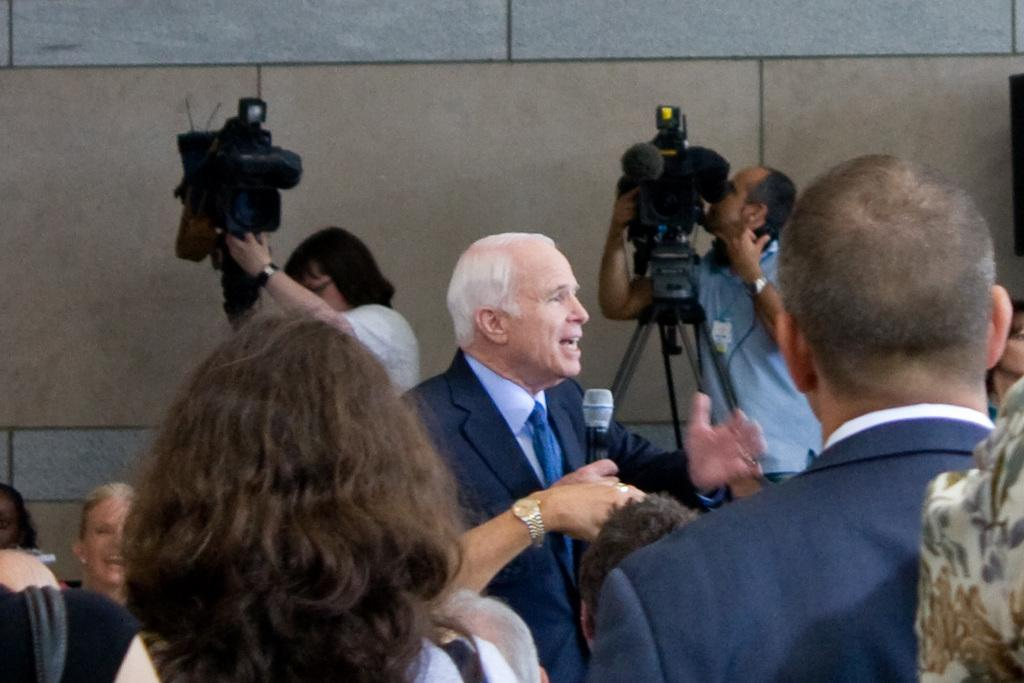How many people are in the image? There is a group of people in the image. What is the person in front wearing? The person in front is wearing a black blazer. What is the person in front holding? The person in front is holding a microphone. What can be seen in the background of the image? There are two cameras in the background, and the wall has brown and gray colors. Is the father in the image holding an umbrella to protect the group from the rain? There is no mention of rain or an umbrella in the image, nor is there any reference to a father. 